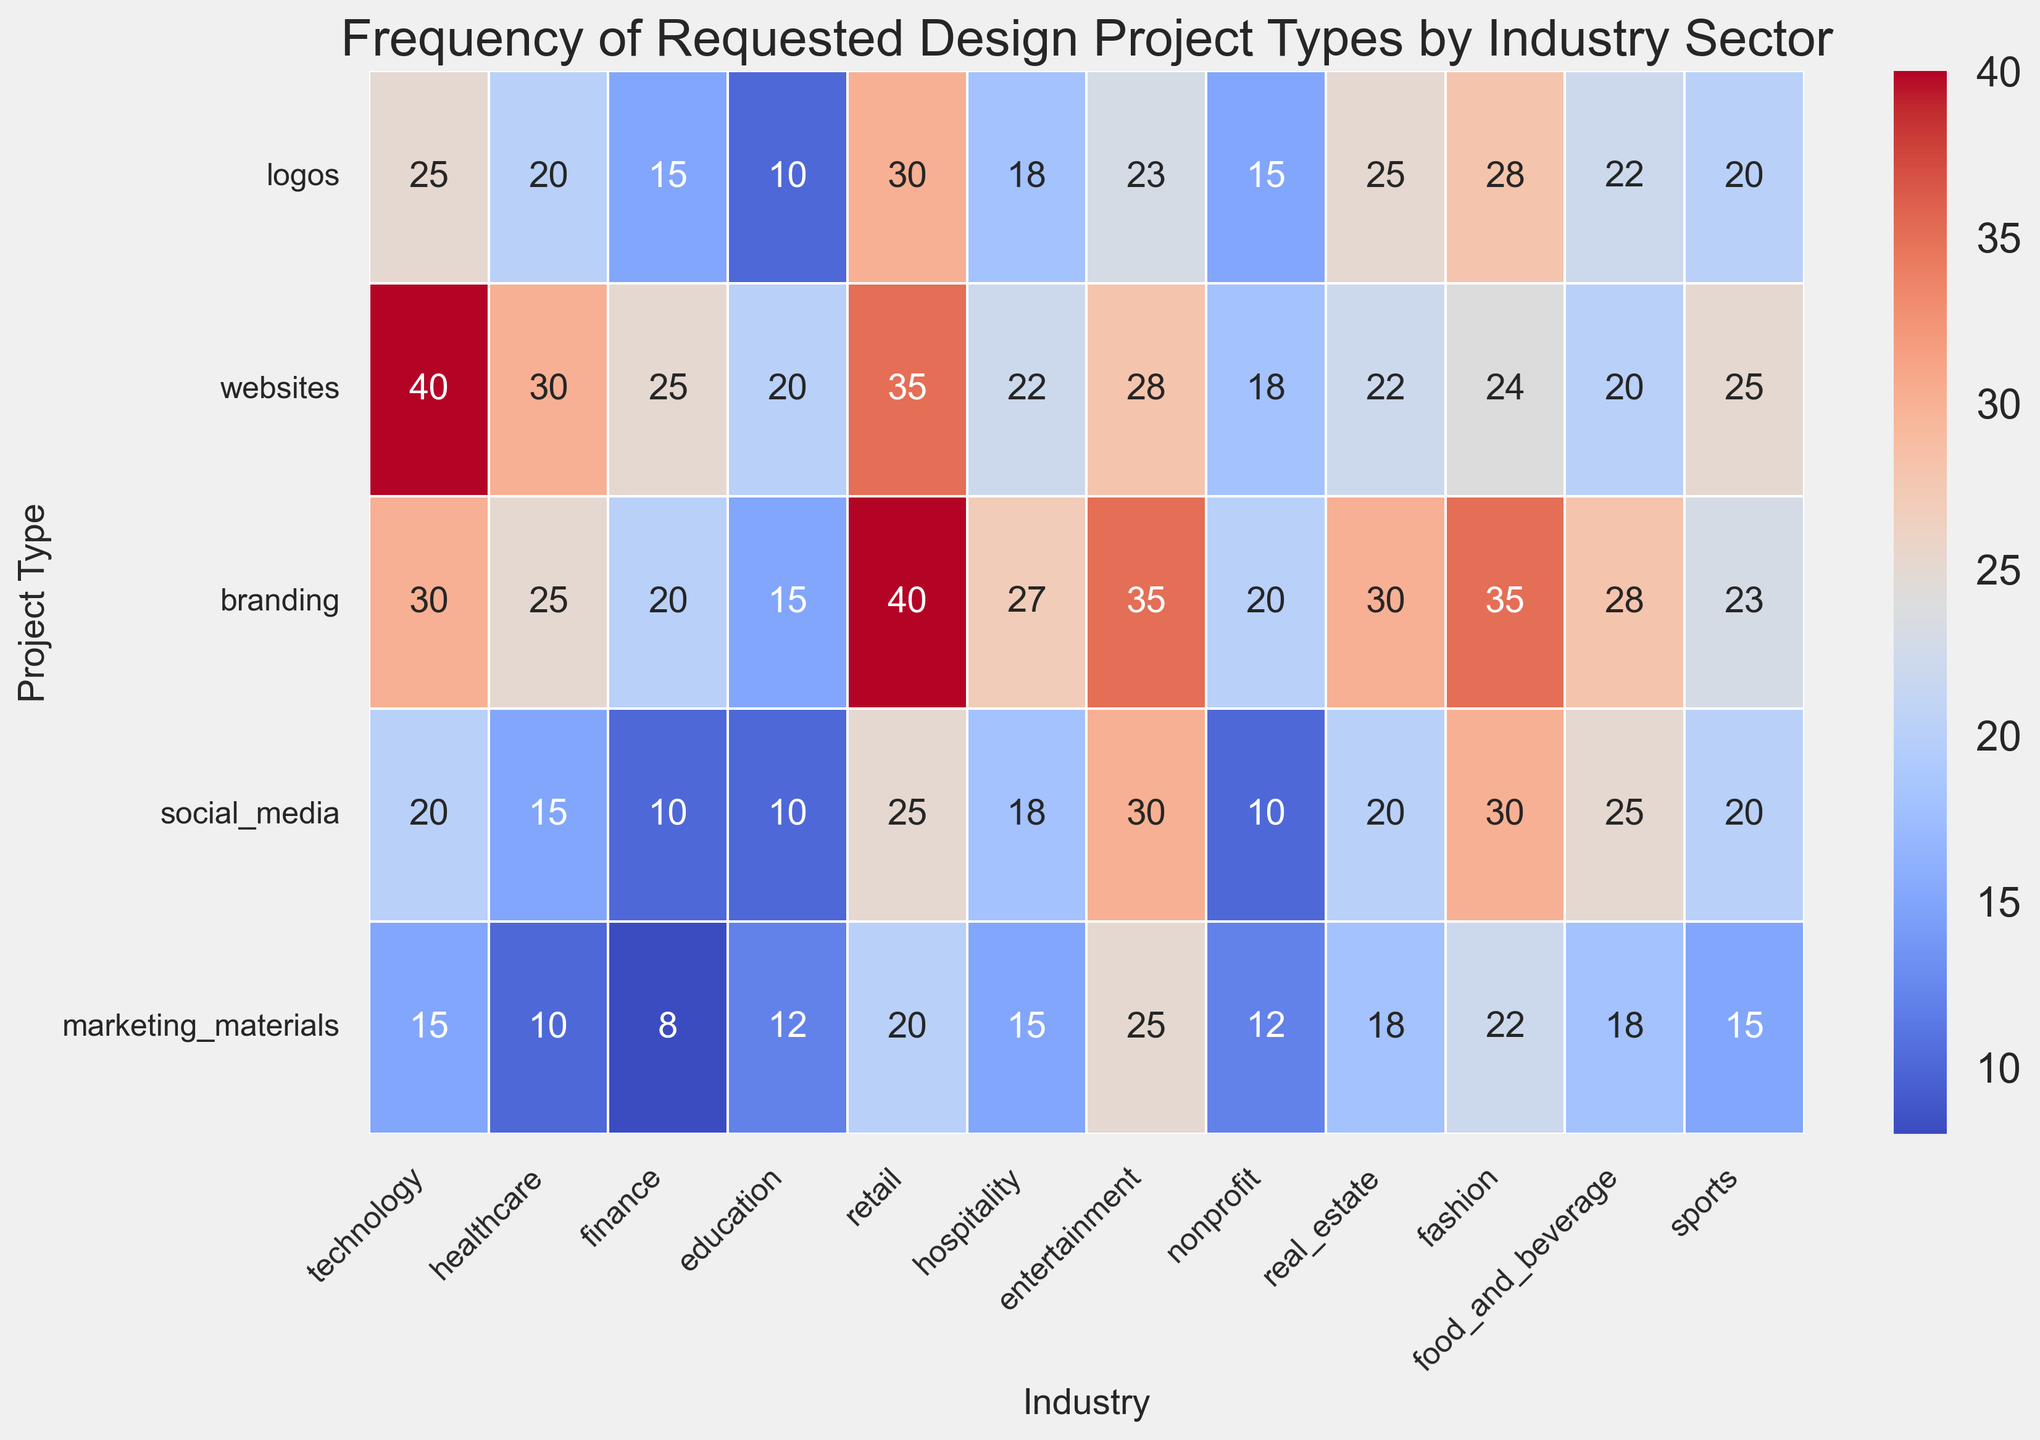Which industry sector requests the most branding projects? First, scan along the "branding" row and identify the highest number. The highest number is 40 under the "retail" column.
Answer: retail Compare the frequency of website design requests between the technology and finance sectors. Which one is higher? Compare the numbers in the "websites" row for both technology and finance. Technology has 40 and finance has 25. 40 is greater than 25.
Answer: technology What is the total number of project requests for social media and marketing materials combined in the entertainment sector? Find the numbers for "social_media" and "marketing_materials" in the entertainment column, which are 30 and 25 respectively. Sum them: 30 + 25 = 55.
Answer: 55 Which project type has the least frequency in the healthcare sector? Identify the smallest number in the healthcare column. The numbers are 20, 30, 25, 15, and 10. The smallest is 10 for "marketing_materials".
Answer: marketing_materials For the fashion sector, is the frequency of logo requests greater than the frequency of website requests? Compare the numbers in the fashion column for "logos" and "websites". Logos have 28, and websites have 24. 28 is greater than 24.
Answer: Yes Calculate the average frequency of branding project requests across all industries. First, sum the values for "branding" across all industries: 30 + 25 + 20 + 15 + 40 + 27 + 35 + 20 + 30 + 35 + 28 + 23 = 328. Then, divide by the number of industries (12): 328 / 12 ≈ 27.33.
Answer: 27.33 Which industry has the highest total number of project requests for all types combined? Add up all project requests for each industry and compare. The sector with the highest total will be the answer. For example, retail has 30+35+40+25+20 = 150. Similar calculations for each sector show retail has the highest total.
Answer: retail What is the color indicating the highest number of requests in the heatmap? Look for the most intense color in the heatmap legend which indicates the highest number, typically a strong red in a "coolwarm" colormap.
Answer: red Is the number of social media project requests in the sports sector less than that in the food and beverage sector? Look at the "social_media" row for both sports and food_and_beverage columns. Sports has 20, and food_and_beverage has 25. 20 is less than 25.
Answer: Yes 